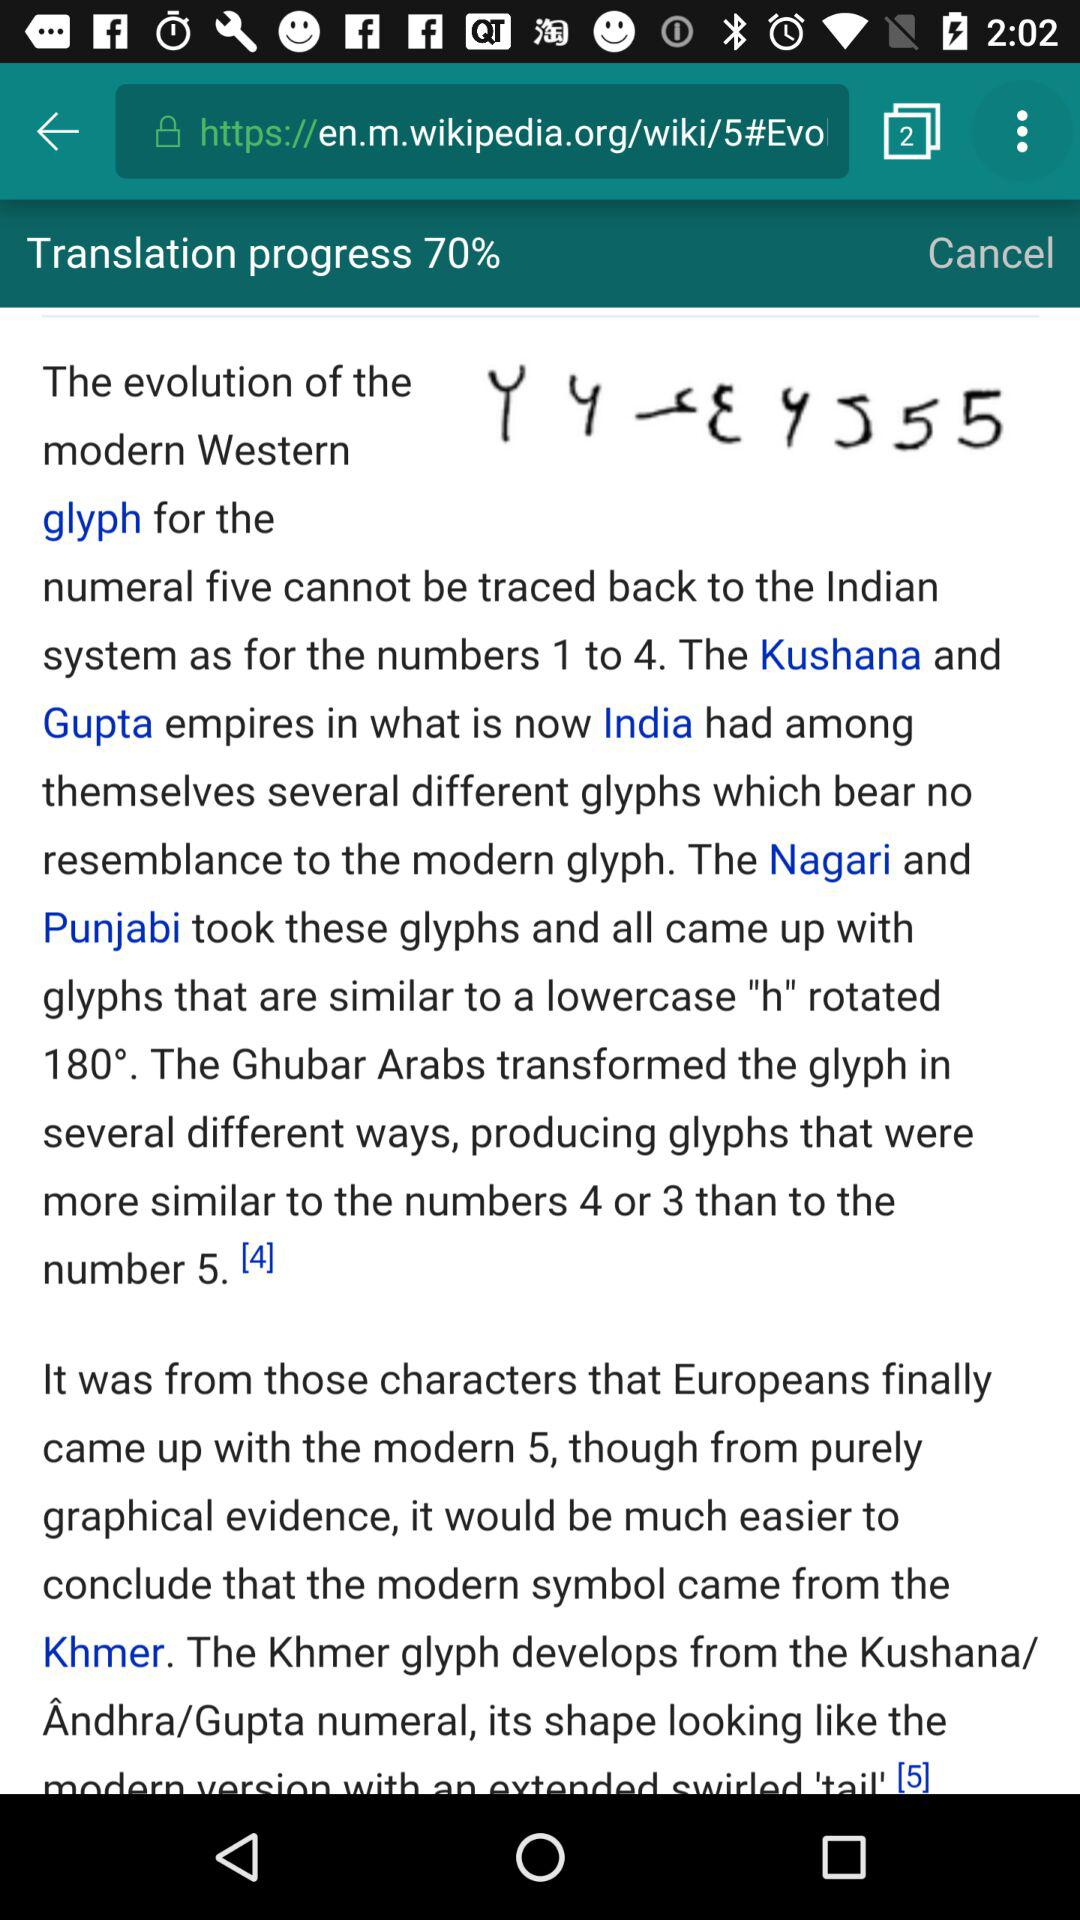What is the username?
When the provided information is insufficient, respond with <no answer>. <no answer> 